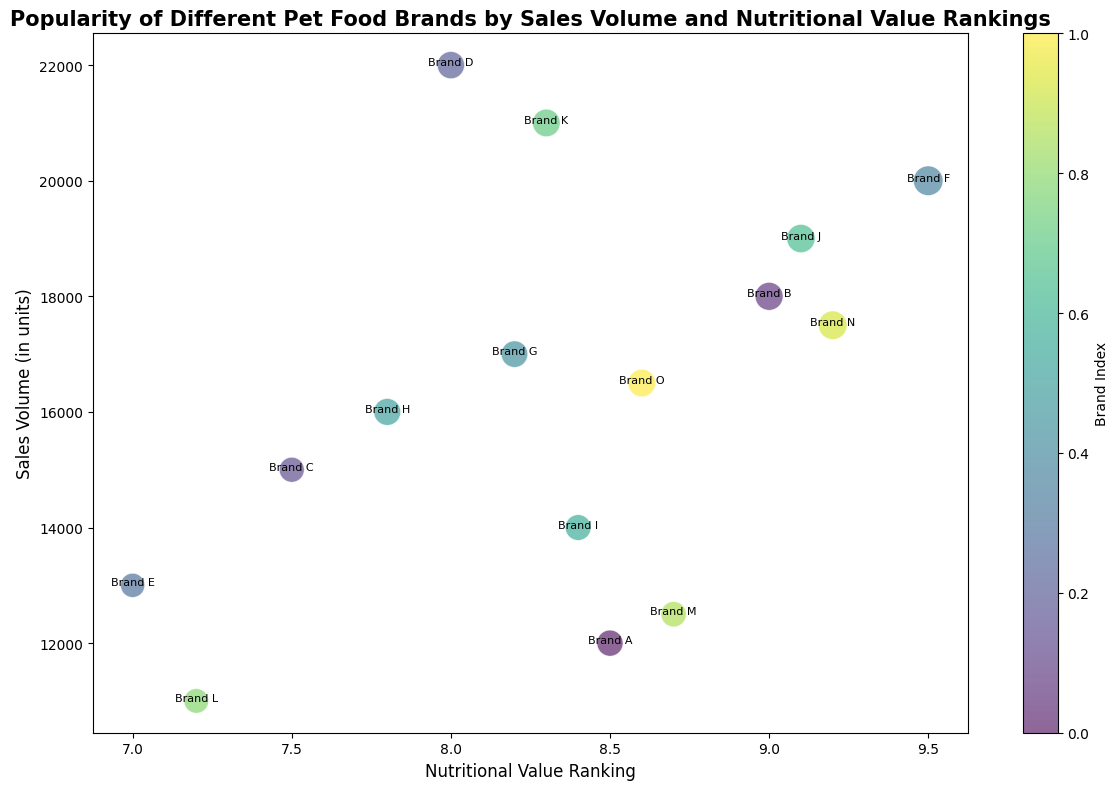Which brand has the highest sales volume? The tallest bubble on the y-axis represents the brand with the highest sales volume. Here, Brand D is the tallest, which means it has the highest sales volume.
Answer: Brand D Which brand has the highest nutritional value ranking? The bubble farthest to the right on the x-axis represents the brand with the highest nutritional value ranking. Here, Brand F is the farthest right, indicating it has the highest nutritional value ranking.
Answer: Brand F Which brand has the smallest bubble size? Bubble sizes are proportional to the average price. The smallest bubble size visually corresponds to the lowest average price. By inspection, Brand E appears to have the smallest bubble.
Answer: Brand E Which brands have both a nutritional value ranking greater than 8.5 and a sales volume above 16000 units? To find this, look for bubbles positioned to the right of the 8.5 mark on the x-axis and above the 16000 mark on the y-axis. Brands B, F, I, J, N qualify.
Answer: Brands B, F, J, N What is the difference in sales volume between the brands with the highest and lowest nutritional value ranking? The sales volume for Brand F (highest ranking) is 20000 units, and for Brand E (lowest ranking) is 13000 units. The difference is 20000 - 13000.
Answer: 7000 units Which brand has the highest average price, and what is that price? The largest bubble size indicates the highest average price. The largest bubble corresponds to Brand F. By checking the data, Brand F has an average price of $4.5.
Answer: Brand F, $4.5 Which brand is closest to having equal nutritional value ranking and sales volume when considering their relative scales? Examine which bubble is closest to forming a line where the x and y values are proportional. Brand O visually appears closest to having its numerical values align relatively similarly.
Answer: Brand O How do the sales volumes of brands with a nutritional value ranking of 8.0 compare? Identify bubbles around the 8.0 mark on the x-axis. Brands D and G have rankings around 8.0. Brand D has a higher sales volume compared to Brand G.
Answer: Brand D > Brand G What's the difference in sales volume between Brands with the highest and second-highest sales volumes? Identifying the highest (Brand D at 22000 units) and the second-highest (Brand K at 21000 units), the difference is 22000 - 21000.
Answer: 1000 units 